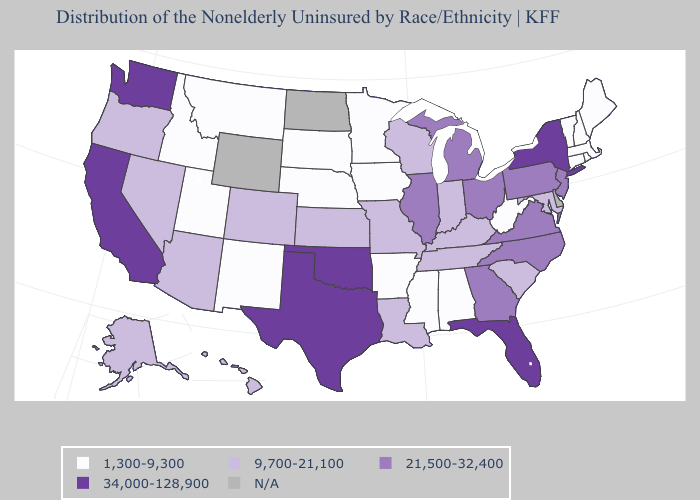What is the value of Maryland?
Write a very short answer. 9,700-21,100. Does Iowa have the lowest value in the USA?
Answer briefly. Yes. Name the states that have a value in the range 21,500-32,400?
Quick response, please. Georgia, Illinois, Michigan, New Jersey, North Carolina, Ohio, Pennsylvania, Virginia. What is the value of Montana?
Write a very short answer. 1,300-9,300. What is the value of Maryland?
Give a very brief answer. 9,700-21,100. What is the lowest value in the USA?
Write a very short answer. 1,300-9,300. What is the highest value in states that border Ohio?
Short answer required. 21,500-32,400. What is the lowest value in the USA?
Short answer required. 1,300-9,300. Name the states that have a value in the range 21,500-32,400?
Give a very brief answer. Georgia, Illinois, Michigan, New Jersey, North Carolina, Ohio, Pennsylvania, Virginia. Name the states that have a value in the range N/A?
Give a very brief answer. Delaware, North Dakota, Wyoming. Among the states that border North Carolina , does Tennessee have the lowest value?
Write a very short answer. Yes. Name the states that have a value in the range 9,700-21,100?
Concise answer only. Alaska, Arizona, Colorado, Hawaii, Indiana, Kansas, Kentucky, Louisiana, Maryland, Missouri, Nevada, Oregon, South Carolina, Tennessee, Wisconsin. Which states have the highest value in the USA?
Write a very short answer. California, Florida, New York, Oklahoma, Texas, Washington. How many symbols are there in the legend?
Short answer required. 5. 